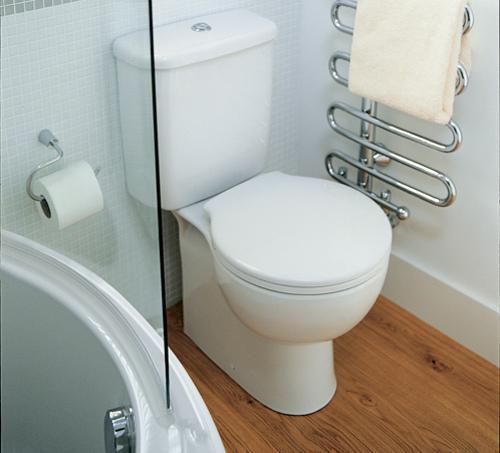How many toilets are there?
Give a very brief answer. 1. 